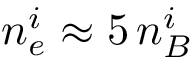<formula> <loc_0><loc_0><loc_500><loc_500>n _ { e } ^ { i } \approx 5 \, n _ { B } ^ { i }</formula> 